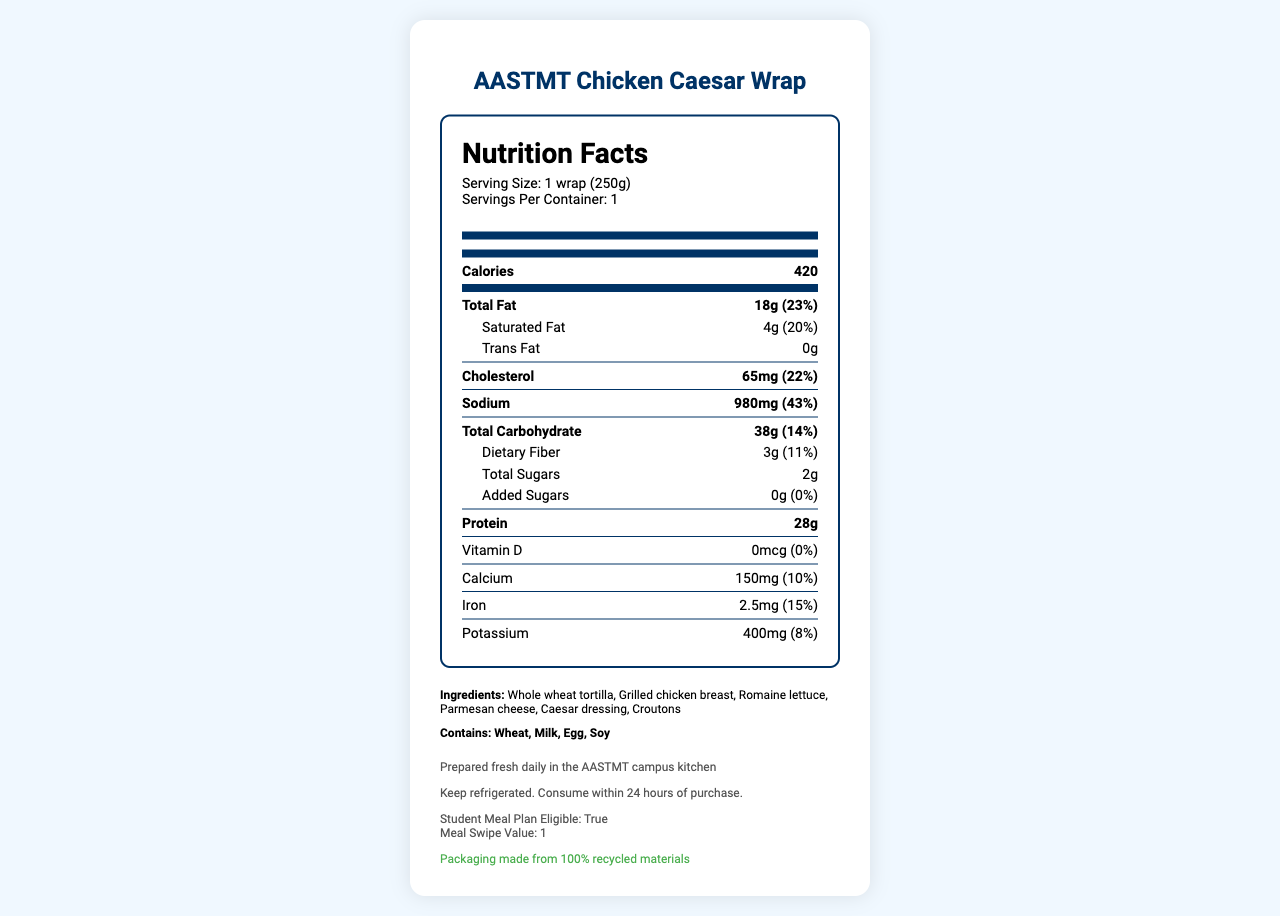what is the serving size for the AASTMT Chicken Caesar Wrap? The document specifies the serving size as "1 wrap (250g)" under the product name and serving information section.
Answer: 1 wrap (250g) How many calories are in one serving of the AASTMT Chicken Caesar Wrap? The document shows the calorie content as "420" in the main nutrition facts section.
Answer: 420 what is the total fat content per serving? The document lists "Total Fat" as "18g" with a daily value percentage of "23%" in the nutrition facts.
Answer: 18g how many grams of protein does the wrap contain? The nutrition facts section indicates that the wrap contains "28g" of protein.
Answer: 28g What allergens are present in the AASTMT Chicken Caesar Wrap? The allergens are listed in the section labeled "Contains" and include "Wheat, Milk, Egg, Soy".
Answer: Wheat, Milk, Egg, Soy How much sodium is in the wrap? A. 500mg B. 750mg C. 980mg The sodium content is listed as "980mg" with a daily value percentage of "43%" in the nutrition facts.
Answer: C. 980mg What is the daily value percentage for dietary fiber? A. 5% B. 11% C. 15% The document shows that the daily value percentage for dietary fiber is "11%".
Answer: B. 11% Does the wrap contain any trans fat? The nutrition facts state "Trans Fat 0g", indicating that the wrap contains no trans fat.
Answer: No Is the AASTMT Chicken Caesar Wrap eligible for the student meal plan? The additional information section notes that the wrap is "Student Meal Plan Eligible: true".
Answer: Yes Can the amount of Vitamin D in the wrap be determined from the document? The Vitamin D amount is listed as "0mcg", but this means there is no measurable Vitamin D content in the wrap, so the exact amount cannot be determined.
Answer: No Summarize the details provided in the document about the AASTMT Chicken Caesar Wrap. The document includes various sections such as a nutrition label, a list of ingredients and allergens, preparation and storage instructions, and notes on meal plan eligibility and sustainability. All these details paint a comprehensive picture of the wrap's nutritional profile and specific considerations.
Answer: The document provides detailed nutritional information, ingredients, allergens, preparation, and storage instructions for the AASTMT Chicken Caesar Wrap. It has 420 calories, 18g of total fat, 28g of protein, and other nutritional metrics such as sodium (980mg) and dietary fiber (3g). The wrap contains allergens like wheat, milk, egg, and soy. It is prepared fresh daily in the campus kitchen and must be refrigerated and consumed within 24 hours of purchase. The wrap is eligible for the student meal plan and uses sustainable packaging. 